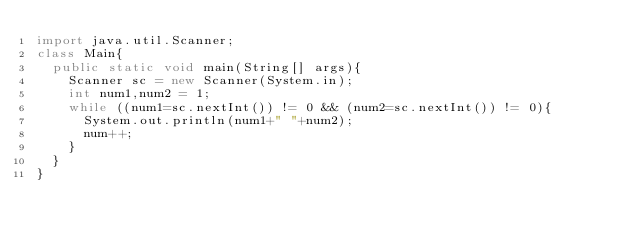Convert code to text. <code><loc_0><loc_0><loc_500><loc_500><_Java_>import java.util.Scanner;
class Main{
  public static void main(String[] args){
    Scanner sc = new Scanner(System.in);
    int num1,num2 = 1;
    while ((num1=sc.nextInt()) != 0 && (num2=sc.nextInt()) != 0){
      System.out.println(num1+" "+num2);
      num++;
    }
  }
}

</code> 